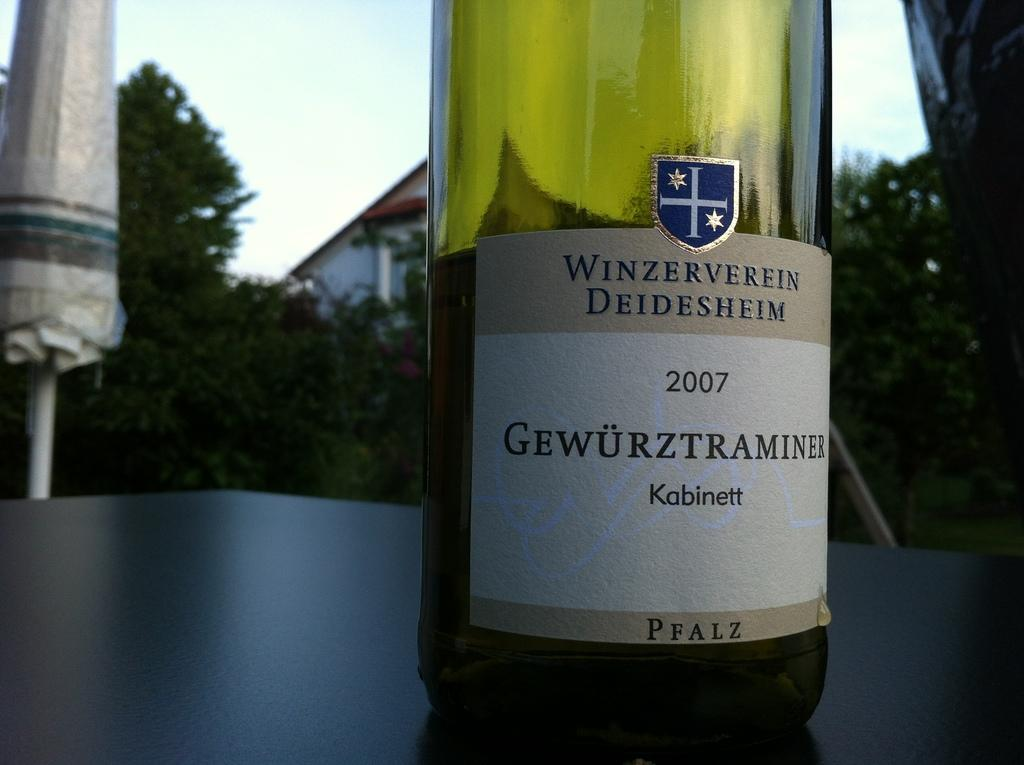<image>
Write a terse but informative summary of the picture. the year 2007 is on the wine bottle 